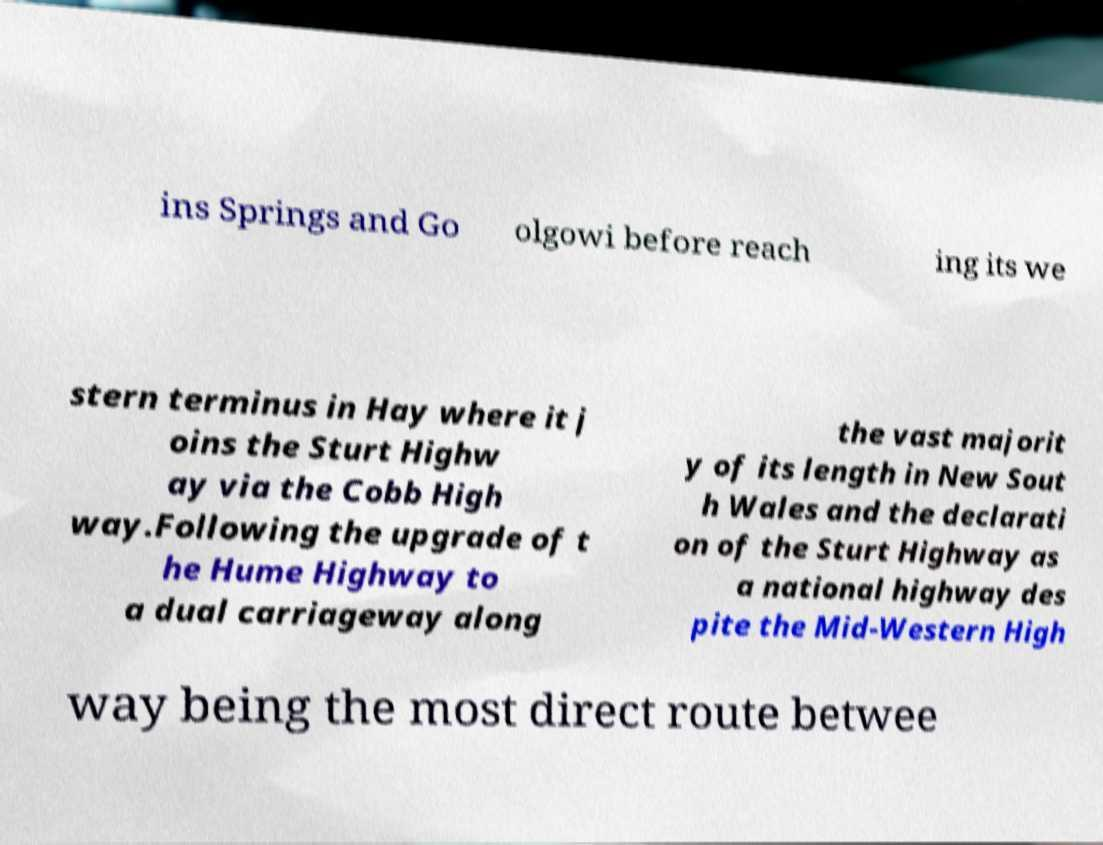Could you extract and type out the text from this image? ins Springs and Go olgowi before reach ing its we stern terminus in Hay where it j oins the Sturt Highw ay via the Cobb High way.Following the upgrade of t he Hume Highway to a dual carriageway along the vast majorit y of its length in New Sout h Wales and the declarati on of the Sturt Highway as a national highway des pite the Mid-Western High way being the most direct route betwee 